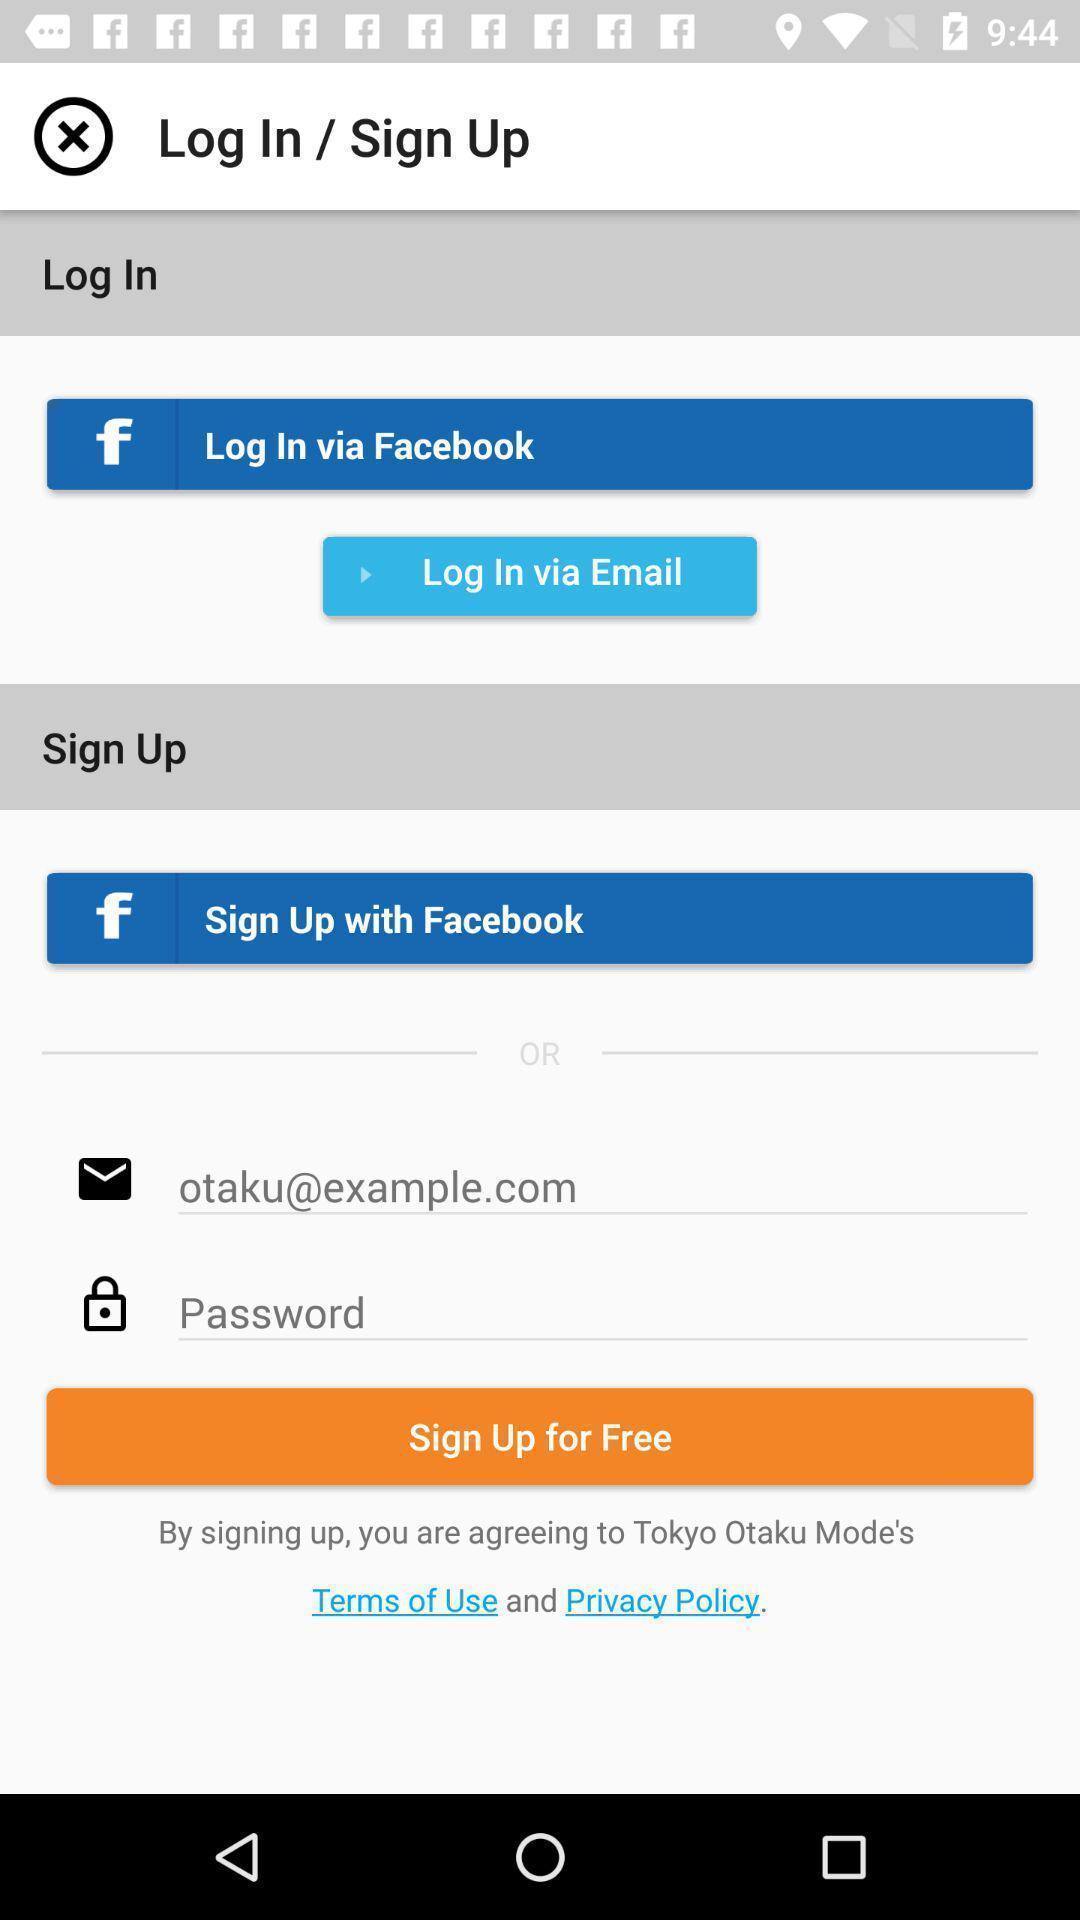Describe the content in this image. Login page of an e-commerce app. 